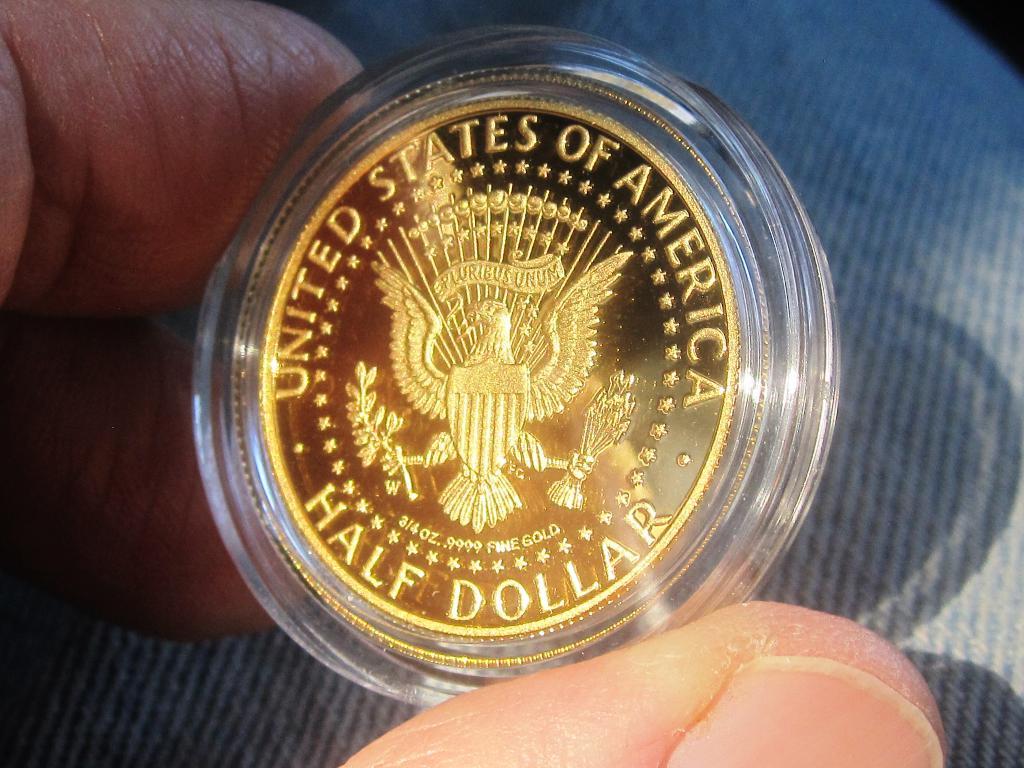How much is this worth?
Give a very brief answer. Half dollar. Which countries coin is this?
Ensure brevity in your answer.  United states of america. 